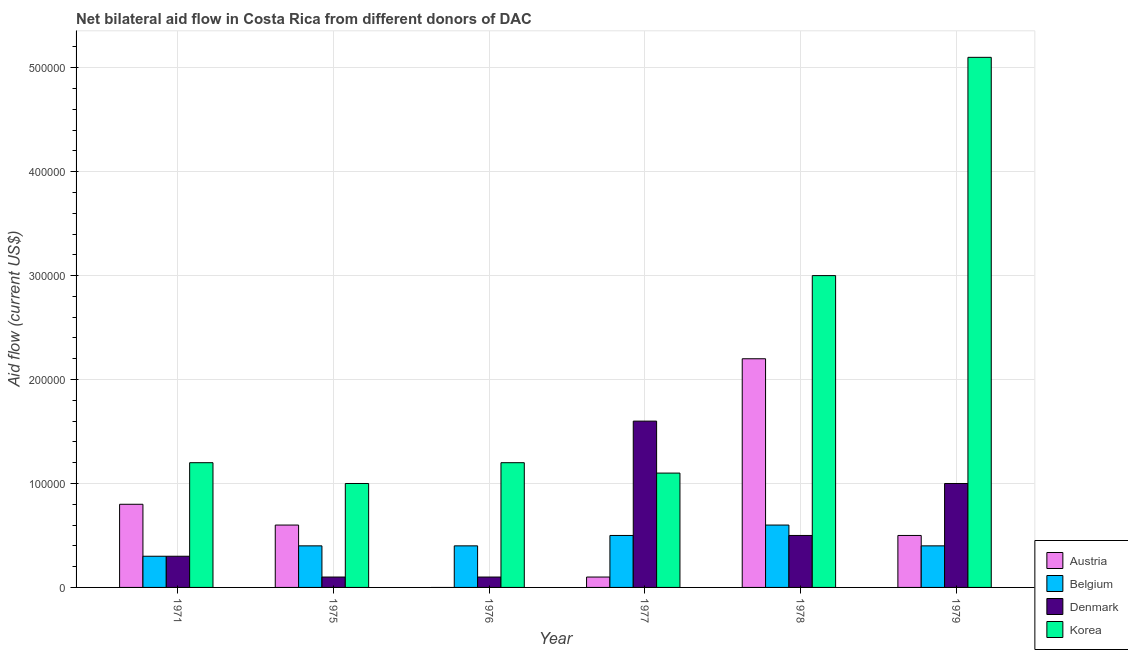How many different coloured bars are there?
Provide a short and direct response. 4. How many groups of bars are there?
Provide a succinct answer. 6. Are the number of bars on each tick of the X-axis equal?
Provide a succinct answer. No. What is the label of the 2nd group of bars from the left?
Your answer should be compact. 1975. In how many cases, is the number of bars for a given year not equal to the number of legend labels?
Offer a very short reply. 1. What is the amount of aid given by denmark in 1979?
Give a very brief answer. 1.00e+05. Across all years, what is the maximum amount of aid given by belgium?
Provide a short and direct response. 6.00e+04. Across all years, what is the minimum amount of aid given by korea?
Provide a succinct answer. 1.00e+05. What is the total amount of aid given by belgium in the graph?
Your response must be concise. 2.60e+05. What is the difference between the amount of aid given by belgium in 1978 and that in 1979?
Ensure brevity in your answer.  2.00e+04. What is the difference between the amount of aid given by denmark in 1979 and the amount of aid given by austria in 1975?
Your answer should be very brief. 9.00e+04. In the year 1976, what is the difference between the amount of aid given by korea and amount of aid given by austria?
Make the answer very short. 0. In how many years, is the amount of aid given by austria greater than 120000 US$?
Make the answer very short. 1. What is the ratio of the amount of aid given by denmark in 1971 to that in 1976?
Provide a succinct answer. 3. Is the difference between the amount of aid given by denmark in 1977 and 1979 greater than the difference between the amount of aid given by belgium in 1977 and 1979?
Offer a terse response. No. What is the difference between the highest and the second highest amount of aid given by austria?
Your answer should be very brief. 1.40e+05. What is the difference between the highest and the lowest amount of aid given by korea?
Make the answer very short. 4.10e+05. In how many years, is the amount of aid given by austria greater than the average amount of aid given by austria taken over all years?
Keep it short and to the point. 2. Is the sum of the amount of aid given by belgium in 1977 and 1979 greater than the maximum amount of aid given by austria across all years?
Make the answer very short. Yes. Is it the case that in every year, the sum of the amount of aid given by austria and amount of aid given by belgium is greater than the amount of aid given by denmark?
Make the answer very short. No. How many bars are there?
Make the answer very short. 23. Are all the bars in the graph horizontal?
Make the answer very short. No. How many years are there in the graph?
Your answer should be compact. 6. What is the difference between two consecutive major ticks on the Y-axis?
Keep it short and to the point. 1.00e+05. Where does the legend appear in the graph?
Keep it short and to the point. Bottom right. What is the title of the graph?
Ensure brevity in your answer.  Net bilateral aid flow in Costa Rica from different donors of DAC. Does "Periodicity assessment" appear as one of the legend labels in the graph?
Keep it short and to the point. No. What is the label or title of the X-axis?
Provide a short and direct response. Year. What is the label or title of the Y-axis?
Offer a very short reply. Aid flow (current US$). What is the Aid flow (current US$) of Austria in 1971?
Your answer should be compact. 8.00e+04. What is the Aid flow (current US$) in Belgium in 1971?
Your response must be concise. 3.00e+04. What is the Aid flow (current US$) in Korea in 1971?
Provide a succinct answer. 1.20e+05. What is the Aid flow (current US$) of Austria in 1975?
Give a very brief answer. 6.00e+04. What is the Aid flow (current US$) in Belgium in 1975?
Make the answer very short. 4.00e+04. What is the Aid flow (current US$) in Belgium in 1976?
Give a very brief answer. 4.00e+04. What is the Aid flow (current US$) of Denmark in 1976?
Provide a succinct answer. 10000. What is the Aid flow (current US$) of Korea in 1976?
Your response must be concise. 1.20e+05. What is the Aid flow (current US$) in Austria in 1977?
Ensure brevity in your answer.  10000. What is the Aid flow (current US$) in Belgium in 1977?
Give a very brief answer. 5.00e+04. What is the Aid flow (current US$) in Denmark in 1977?
Offer a terse response. 1.60e+05. What is the Aid flow (current US$) in Austria in 1978?
Offer a terse response. 2.20e+05. What is the Aid flow (current US$) in Belgium in 1978?
Provide a short and direct response. 6.00e+04. What is the Aid flow (current US$) of Denmark in 1978?
Provide a succinct answer. 5.00e+04. What is the Aid flow (current US$) of Korea in 1978?
Provide a succinct answer. 3.00e+05. What is the Aid flow (current US$) of Austria in 1979?
Make the answer very short. 5.00e+04. What is the Aid flow (current US$) in Belgium in 1979?
Provide a short and direct response. 4.00e+04. What is the Aid flow (current US$) of Korea in 1979?
Ensure brevity in your answer.  5.10e+05. Across all years, what is the maximum Aid flow (current US$) in Denmark?
Make the answer very short. 1.60e+05. Across all years, what is the maximum Aid flow (current US$) in Korea?
Your response must be concise. 5.10e+05. Across all years, what is the minimum Aid flow (current US$) of Denmark?
Offer a very short reply. 10000. Across all years, what is the minimum Aid flow (current US$) of Korea?
Your response must be concise. 1.00e+05. What is the total Aid flow (current US$) of Austria in the graph?
Offer a very short reply. 4.20e+05. What is the total Aid flow (current US$) of Belgium in the graph?
Keep it short and to the point. 2.60e+05. What is the total Aid flow (current US$) of Denmark in the graph?
Provide a short and direct response. 3.60e+05. What is the total Aid flow (current US$) in Korea in the graph?
Your answer should be compact. 1.26e+06. What is the difference between the Aid flow (current US$) in Denmark in 1971 and that in 1975?
Your answer should be very brief. 2.00e+04. What is the difference between the Aid flow (current US$) in Korea in 1971 and that in 1976?
Your response must be concise. 0. What is the difference between the Aid flow (current US$) in Austria in 1971 and that in 1977?
Provide a succinct answer. 7.00e+04. What is the difference between the Aid flow (current US$) in Belgium in 1971 and that in 1977?
Offer a terse response. -2.00e+04. What is the difference between the Aid flow (current US$) in Denmark in 1971 and that in 1977?
Offer a very short reply. -1.30e+05. What is the difference between the Aid flow (current US$) in Korea in 1971 and that in 1977?
Ensure brevity in your answer.  10000. What is the difference between the Aid flow (current US$) in Korea in 1971 and that in 1978?
Ensure brevity in your answer.  -1.80e+05. What is the difference between the Aid flow (current US$) in Austria in 1971 and that in 1979?
Keep it short and to the point. 3.00e+04. What is the difference between the Aid flow (current US$) of Denmark in 1971 and that in 1979?
Keep it short and to the point. -7.00e+04. What is the difference between the Aid flow (current US$) of Korea in 1971 and that in 1979?
Provide a succinct answer. -3.90e+05. What is the difference between the Aid flow (current US$) of Korea in 1975 and that in 1976?
Keep it short and to the point. -2.00e+04. What is the difference between the Aid flow (current US$) in Austria in 1975 and that in 1977?
Offer a terse response. 5.00e+04. What is the difference between the Aid flow (current US$) in Korea in 1975 and that in 1977?
Your answer should be compact. -10000. What is the difference between the Aid flow (current US$) of Denmark in 1975 and that in 1978?
Your answer should be compact. -4.00e+04. What is the difference between the Aid flow (current US$) of Korea in 1975 and that in 1978?
Provide a short and direct response. -2.00e+05. What is the difference between the Aid flow (current US$) in Austria in 1975 and that in 1979?
Your answer should be compact. 10000. What is the difference between the Aid flow (current US$) in Korea in 1975 and that in 1979?
Ensure brevity in your answer.  -4.10e+05. What is the difference between the Aid flow (current US$) of Korea in 1976 and that in 1977?
Keep it short and to the point. 10000. What is the difference between the Aid flow (current US$) of Belgium in 1976 and that in 1978?
Keep it short and to the point. -2.00e+04. What is the difference between the Aid flow (current US$) in Korea in 1976 and that in 1978?
Ensure brevity in your answer.  -1.80e+05. What is the difference between the Aid flow (current US$) in Korea in 1976 and that in 1979?
Make the answer very short. -3.90e+05. What is the difference between the Aid flow (current US$) in Denmark in 1977 and that in 1978?
Offer a very short reply. 1.10e+05. What is the difference between the Aid flow (current US$) in Korea in 1977 and that in 1978?
Provide a succinct answer. -1.90e+05. What is the difference between the Aid flow (current US$) of Austria in 1977 and that in 1979?
Make the answer very short. -4.00e+04. What is the difference between the Aid flow (current US$) of Denmark in 1977 and that in 1979?
Make the answer very short. 6.00e+04. What is the difference between the Aid flow (current US$) of Korea in 1977 and that in 1979?
Provide a succinct answer. -4.00e+05. What is the difference between the Aid flow (current US$) in Austria in 1978 and that in 1979?
Your response must be concise. 1.70e+05. What is the difference between the Aid flow (current US$) in Belgium in 1978 and that in 1979?
Provide a succinct answer. 2.00e+04. What is the difference between the Aid flow (current US$) of Denmark in 1978 and that in 1979?
Provide a short and direct response. -5.00e+04. What is the difference between the Aid flow (current US$) in Korea in 1978 and that in 1979?
Your response must be concise. -2.10e+05. What is the difference between the Aid flow (current US$) in Austria in 1971 and the Aid flow (current US$) in Denmark in 1975?
Offer a very short reply. 7.00e+04. What is the difference between the Aid flow (current US$) of Austria in 1971 and the Aid flow (current US$) of Korea in 1975?
Provide a short and direct response. -2.00e+04. What is the difference between the Aid flow (current US$) of Belgium in 1971 and the Aid flow (current US$) of Korea in 1975?
Your answer should be compact. -7.00e+04. What is the difference between the Aid flow (current US$) of Austria in 1971 and the Aid flow (current US$) of Belgium in 1976?
Your answer should be compact. 4.00e+04. What is the difference between the Aid flow (current US$) of Belgium in 1971 and the Aid flow (current US$) of Denmark in 1976?
Give a very brief answer. 2.00e+04. What is the difference between the Aid flow (current US$) of Austria in 1971 and the Aid flow (current US$) of Denmark in 1977?
Offer a terse response. -8.00e+04. What is the difference between the Aid flow (current US$) of Belgium in 1971 and the Aid flow (current US$) of Denmark in 1977?
Offer a terse response. -1.30e+05. What is the difference between the Aid flow (current US$) of Denmark in 1971 and the Aid flow (current US$) of Korea in 1977?
Give a very brief answer. -8.00e+04. What is the difference between the Aid flow (current US$) in Austria in 1971 and the Aid flow (current US$) in Belgium in 1978?
Ensure brevity in your answer.  2.00e+04. What is the difference between the Aid flow (current US$) in Belgium in 1971 and the Aid flow (current US$) in Korea in 1978?
Ensure brevity in your answer.  -2.70e+05. What is the difference between the Aid flow (current US$) of Denmark in 1971 and the Aid flow (current US$) of Korea in 1978?
Provide a short and direct response. -2.70e+05. What is the difference between the Aid flow (current US$) in Austria in 1971 and the Aid flow (current US$) in Belgium in 1979?
Your response must be concise. 4.00e+04. What is the difference between the Aid flow (current US$) of Austria in 1971 and the Aid flow (current US$) of Denmark in 1979?
Provide a succinct answer. -2.00e+04. What is the difference between the Aid flow (current US$) of Austria in 1971 and the Aid flow (current US$) of Korea in 1979?
Your response must be concise. -4.30e+05. What is the difference between the Aid flow (current US$) in Belgium in 1971 and the Aid flow (current US$) in Denmark in 1979?
Your response must be concise. -7.00e+04. What is the difference between the Aid flow (current US$) of Belgium in 1971 and the Aid flow (current US$) of Korea in 1979?
Offer a terse response. -4.80e+05. What is the difference between the Aid flow (current US$) of Denmark in 1971 and the Aid flow (current US$) of Korea in 1979?
Keep it short and to the point. -4.80e+05. What is the difference between the Aid flow (current US$) in Austria in 1975 and the Aid flow (current US$) in Belgium in 1976?
Keep it short and to the point. 2.00e+04. What is the difference between the Aid flow (current US$) of Belgium in 1975 and the Aid flow (current US$) of Korea in 1976?
Your answer should be very brief. -8.00e+04. What is the difference between the Aid flow (current US$) of Denmark in 1975 and the Aid flow (current US$) of Korea in 1976?
Your answer should be compact. -1.10e+05. What is the difference between the Aid flow (current US$) in Austria in 1975 and the Aid flow (current US$) in Belgium in 1977?
Provide a short and direct response. 10000. What is the difference between the Aid flow (current US$) of Austria in 1975 and the Aid flow (current US$) of Denmark in 1977?
Offer a very short reply. -1.00e+05. What is the difference between the Aid flow (current US$) in Austria in 1975 and the Aid flow (current US$) in Korea in 1977?
Your answer should be compact. -5.00e+04. What is the difference between the Aid flow (current US$) of Belgium in 1975 and the Aid flow (current US$) of Denmark in 1977?
Offer a terse response. -1.20e+05. What is the difference between the Aid flow (current US$) in Denmark in 1975 and the Aid flow (current US$) in Korea in 1977?
Make the answer very short. -1.00e+05. What is the difference between the Aid flow (current US$) of Austria in 1975 and the Aid flow (current US$) of Belgium in 1978?
Make the answer very short. 0. What is the difference between the Aid flow (current US$) in Austria in 1975 and the Aid flow (current US$) in Denmark in 1978?
Your answer should be compact. 10000. What is the difference between the Aid flow (current US$) in Austria in 1975 and the Aid flow (current US$) in Korea in 1978?
Offer a very short reply. -2.40e+05. What is the difference between the Aid flow (current US$) in Belgium in 1975 and the Aid flow (current US$) in Korea in 1978?
Provide a short and direct response. -2.60e+05. What is the difference between the Aid flow (current US$) in Denmark in 1975 and the Aid flow (current US$) in Korea in 1978?
Give a very brief answer. -2.90e+05. What is the difference between the Aid flow (current US$) of Austria in 1975 and the Aid flow (current US$) of Denmark in 1979?
Your answer should be very brief. -4.00e+04. What is the difference between the Aid flow (current US$) of Austria in 1975 and the Aid flow (current US$) of Korea in 1979?
Your answer should be very brief. -4.50e+05. What is the difference between the Aid flow (current US$) of Belgium in 1975 and the Aid flow (current US$) of Korea in 1979?
Your answer should be compact. -4.70e+05. What is the difference between the Aid flow (current US$) of Denmark in 1975 and the Aid flow (current US$) of Korea in 1979?
Offer a very short reply. -5.00e+05. What is the difference between the Aid flow (current US$) in Denmark in 1976 and the Aid flow (current US$) in Korea in 1977?
Keep it short and to the point. -1.00e+05. What is the difference between the Aid flow (current US$) of Belgium in 1976 and the Aid flow (current US$) of Korea in 1978?
Provide a succinct answer. -2.60e+05. What is the difference between the Aid flow (current US$) of Belgium in 1976 and the Aid flow (current US$) of Denmark in 1979?
Make the answer very short. -6.00e+04. What is the difference between the Aid flow (current US$) of Belgium in 1976 and the Aid flow (current US$) of Korea in 1979?
Ensure brevity in your answer.  -4.70e+05. What is the difference between the Aid flow (current US$) of Denmark in 1976 and the Aid flow (current US$) of Korea in 1979?
Make the answer very short. -5.00e+05. What is the difference between the Aid flow (current US$) of Austria in 1977 and the Aid flow (current US$) of Belgium in 1978?
Your answer should be very brief. -5.00e+04. What is the difference between the Aid flow (current US$) of Austria in 1977 and the Aid flow (current US$) of Korea in 1978?
Your response must be concise. -2.90e+05. What is the difference between the Aid flow (current US$) in Denmark in 1977 and the Aid flow (current US$) in Korea in 1978?
Provide a succinct answer. -1.40e+05. What is the difference between the Aid flow (current US$) in Austria in 1977 and the Aid flow (current US$) in Denmark in 1979?
Offer a very short reply. -9.00e+04. What is the difference between the Aid flow (current US$) in Austria in 1977 and the Aid flow (current US$) in Korea in 1979?
Your answer should be compact. -5.00e+05. What is the difference between the Aid flow (current US$) in Belgium in 1977 and the Aid flow (current US$) in Denmark in 1979?
Make the answer very short. -5.00e+04. What is the difference between the Aid flow (current US$) in Belgium in 1977 and the Aid flow (current US$) in Korea in 1979?
Offer a very short reply. -4.60e+05. What is the difference between the Aid flow (current US$) of Denmark in 1977 and the Aid flow (current US$) of Korea in 1979?
Keep it short and to the point. -3.50e+05. What is the difference between the Aid flow (current US$) of Austria in 1978 and the Aid flow (current US$) of Belgium in 1979?
Offer a terse response. 1.80e+05. What is the difference between the Aid flow (current US$) of Austria in 1978 and the Aid flow (current US$) of Denmark in 1979?
Provide a succinct answer. 1.20e+05. What is the difference between the Aid flow (current US$) in Austria in 1978 and the Aid flow (current US$) in Korea in 1979?
Offer a very short reply. -2.90e+05. What is the difference between the Aid flow (current US$) of Belgium in 1978 and the Aid flow (current US$) of Korea in 1979?
Offer a very short reply. -4.50e+05. What is the difference between the Aid flow (current US$) of Denmark in 1978 and the Aid flow (current US$) of Korea in 1979?
Your answer should be compact. -4.60e+05. What is the average Aid flow (current US$) in Austria per year?
Keep it short and to the point. 7.00e+04. What is the average Aid flow (current US$) of Belgium per year?
Your answer should be very brief. 4.33e+04. What is the average Aid flow (current US$) of Denmark per year?
Offer a terse response. 6.00e+04. What is the average Aid flow (current US$) in Korea per year?
Offer a terse response. 2.10e+05. In the year 1971, what is the difference between the Aid flow (current US$) in Austria and Aid flow (current US$) in Denmark?
Your answer should be very brief. 5.00e+04. In the year 1971, what is the difference between the Aid flow (current US$) of Austria and Aid flow (current US$) of Korea?
Your response must be concise. -4.00e+04. In the year 1975, what is the difference between the Aid flow (current US$) of Austria and Aid flow (current US$) of Denmark?
Offer a terse response. 5.00e+04. In the year 1975, what is the difference between the Aid flow (current US$) of Austria and Aid flow (current US$) of Korea?
Ensure brevity in your answer.  -4.00e+04. In the year 1975, what is the difference between the Aid flow (current US$) of Belgium and Aid flow (current US$) of Denmark?
Offer a terse response. 3.00e+04. In the year 1975, what is the difference between the Aid flow (current US$) of Denmark and Aid flow (current US$) of Korea?
Your response must be concise. -9.00e+04. In the year 1976, what is the difference between the Aid flow (current US$) of Belgium and Aid flow (current US$) of Denmark?
Provide a succinct answer. 3.00e+04. In the year 1976, what is the difference between the Aid flow (current US$) of Denmark and Aid flow (current US$) of Korea?
Offer a very short reply. -1.10e+05. In the year 1977, what is the difference between the Aid flow (current US$) in Austria and Aid flow (current US$) in Belgium?
Your response must be concise. -4.00e+04. In the year 1977, what is the difference between the Aid flow (current US$) in Austria and Aid flow (current US$) in Denmark?
Provide a succinct answer. -1.50e+05. In the year 1977, what is the difference between the Aid flow (current US$) in Belgium and Aid flow (current US$) in Denmark?
Offer a terse response. -1.10e+05. In the year 1977, what is the difference between the Aid flow (current US$) of Belgium and Aid flow (current US$) of Korea?
Provide a succinct answer. -6.00e+04. In the year 1977, what is the difference between the Aid flow (current US$) in Denmark and Aid flow (current US$) in Korea?
Ensure brevity in your answer.  5.00e+04. In the year 1978, what is the difference between the Aid flow (current US$) in Austria and Aid flow (current US$) in Belgium?
Keep it short and to the point. 1.60e+05. In the year 1978, what is the difference between the Aid flow (current US$) in Belgium and Aid flow (current US$) in Denmark?
Provide a succinct answer. 10000. In the year 1979, what is the difference between the Aid flow (current US$) in Austria and Aid flow (current US$) in Belgium?
Offer a very short reply. 10000. In the year 1979, what is the difference between the Aid flow (current US$) of Austria and Aid flow (current US$) of Korea?
Your response must be concise. -4.60e+05. In the year 1979, what is the difference between the Aid flow (current US$) of Belgium and Aid flow (current US$) of Denmark?
Make the answer very short. -6.00e+04. In the year 1979, what is the difference between the Aid flow (current US$) of Belgium and Aid flow (current US$) of Korea?
Give a very brief answer. -4.70e+05. In the year 1979, what is the difference between the Aid flow (current US$) of Denmark and Aid flow (current US$) of Korea?
Your response must be concise. -4.10e+05. What is the ratio of the Aid flow (current US$) of Austria in 1971 to that in 1975?
Keep it short and to the point. 1.33. What is the ratio of the Aid flow (current US$) of Denmark in 1971 to that in 1975?
Keep it short and to the point. 3. What is the ratio of the Aid flow (current US$) in Belgium in 1971 to that in 1976?
Provide a short and direct response. 0.75. What is the ratio of the Aid flow (current US$) in Korea in 1971 to that in 1976?
Ensure brevity in your answer.  1. What is the ratio of the Aid flow (current US$) of Austria in 1971 to that in 1977?
Your answer should be compact. 8. What is the ratio of the Aid flow (current US$) of Belgium in 1971 to that in 1977?
Offer a very short reply. 0.6. What is the ratio of the Aid flow (current US$) in Denmark in 1971 to that in 1977?
Your answer should be compact. 0.19. What is the ratio of the Aid flow (current US$) in Austria in 1971 to that in 1978?
Offer a very short reply. 0.36. What is the ratio of the Aid flow (current US$) of Belgium in 1971 to that in 1978?
Offer a very short reply. 0.5. What is the ratio of the Aid flow (current US$) of Belgium in 1971 to that in 1979?
Offer a very short reply. 0.75. What is the ratio of the Aid flow (current US$) in Denmark in 1971 to that in 1979?
Offer a very short reply. 0.3. What is the ratio of the Aid flow (current US$) of Korea in 1971 to that in 1979?
Give a very brief answer. 0.24. What is the ratio of the Aid flow (current US$) in Belgium in 1975 to that in 1976?
Your answer should be compact. 1. What is the ratio of the Aid flow (current US$) in Denmark in 1975 to that in 1976?
Your response must be concise. 1. What is the ratio of the Aid flow (current US$) of Korea in 1975 to that in 1976?
Your answer should be very brief. 0.83. What is the ratio of the Aid flow (current US$) in Belgium in 1975 to that in 1977?
Ensure brevity in your answer.  0.8. What is the ratio of the Aid flow (current US$) of Denmark in 1975 to that in 1977?
Provide a succinct answer. 0.06. What is the ratio of the Aid flow (current US$) in Austria in 1975 to that in 1978?
Ensure brevity in your answer.  0.27. What is the ratio of the Aid flow (current US$) in Denmark in 1975 to that in 1978?
Your response must be concise. 0.2. What is the ratio of the Aid flow (current US$) in Austria in 1975 to that in 1979?
Ensure brevity in your answer.  1.2. What is the ratio of the Aid flow (current US$) of Belgium in 1975 to that in 1979?
Give a very brief answer. 1. What is the ratio of the Aid flow (current US$) of Korea in 1975 to that in 1979?
Your response must be concise. 0.2. What is the ratio of the Aid flow (current US$) in Denmark in 1976 to that in 1977?
Your answer should be very brief. 0.06. What is the ratio of the Aid flow (current US$) in Belgium in 1976 to that in 1978?
Provide a succinct answer. 0.67. What is the ratio of the Aid flow (current US$) of Korea in 1976 to that in 1978?
Your answer should be very brief. 0.4. What is the ratio of the Aid flow (current US$) of Denmark in 1976 to that in 1979?
Provide a short and direct response. 0.1. What is the ratio of the Aid flow (current US$) in Korea in 1976 to that in 1979?
Provide a succinct answer. 0.24. What is the ratio of the Aid flow (current US$) of Austria in 1977 to that in 1978?
Provide a succinct answer. 0.05. What is the ratio of the Aid flow (current US$) of Korea in 1977 to that in 1978?
Your answer should be compact. 0.37. What is the ratio of the Aid flow (current US$) in Korea in 1977 to that in 1979?
Offer a terse response. 0.22. What is the ratio of the Aid flow (current US$) of Belgium in 1978 to that in 1979?
Provide a succinct answer. 1.5. What is the ratio of the Aid flow (current US$) of Korea in 1978 to that in 1979?
Your response must be concise. 0.59. What is the difference between the highest and the second highest Aid flow (current US$) of Austria?
Make the answer very short. 1.40e+05. What is the difference between the highest and the second highest Aid flow (current US$) of Denmark?
Offer a very short reply. 6.00e+04. What is the difference between the highest and the second highest Aid flow (current US$) of Korea?
Your response must be concise. 2.10e+05. What is the difference between the highest and the lowest Aid flow (current US$) in Korea?
Give a very brief answer. 4.10e+05. 